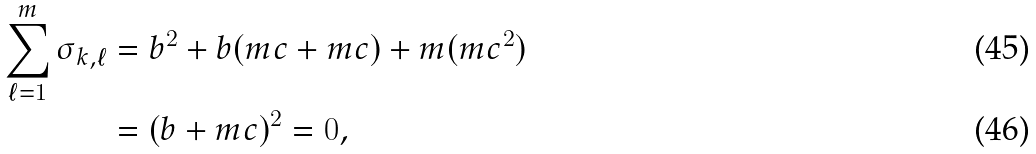Convert formula to latex. <formula><loc_0><loc_0><loc_500><loc_500>\sum _ { \ell = 1 } ^ { m } \sigma _ { k , \ell } & = b ^ { 2 } + b ( m c + m c ) + m ( m c ^ { 2 } ) \\ & = ( b + m c ) ^ { 2 } = 0 ,</formula> 